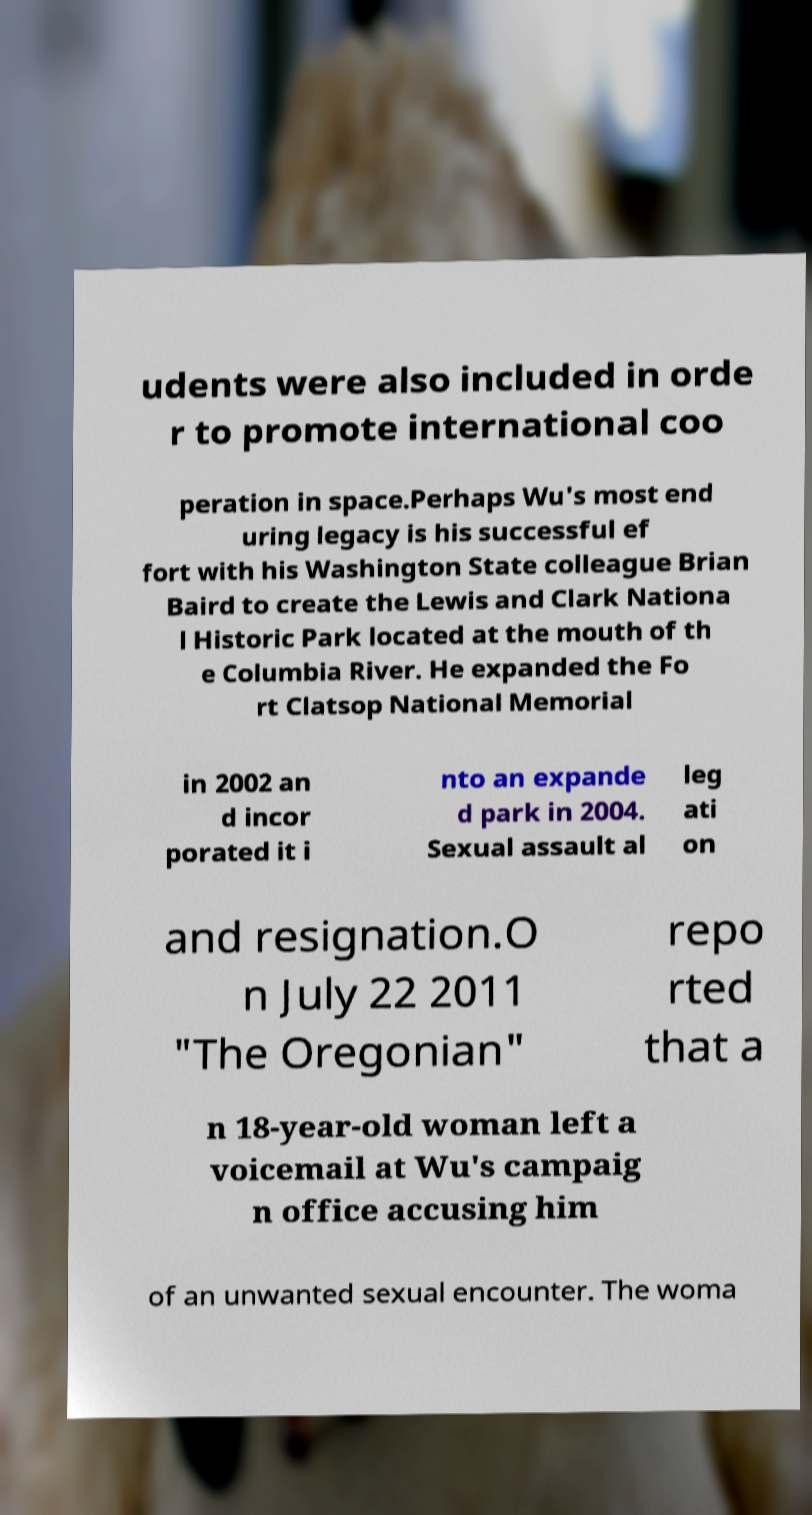Please identify and transcribe the text found in this image. udents were also included in orde r to promote international coo peration in space.Perhaps Wu's most end uring legacy is his successful ef fort with his Washington State colleague Brian Baird to create the Lewis and Clark Nationa l Historic Park located at the mouth of th e Columbia River. He expanded the Fo rt Clatsop National Memorial in 2002 an d incor porated it i nto an expande d park in 2004. Sexual assault al leg ati on and resignation.O n July 22 2011 "The Oregonian" repo rted that a n 18-year-old woman left a voicemail at Wu's campaig n office accusing him of an unwanted sexual encounter. The woma 